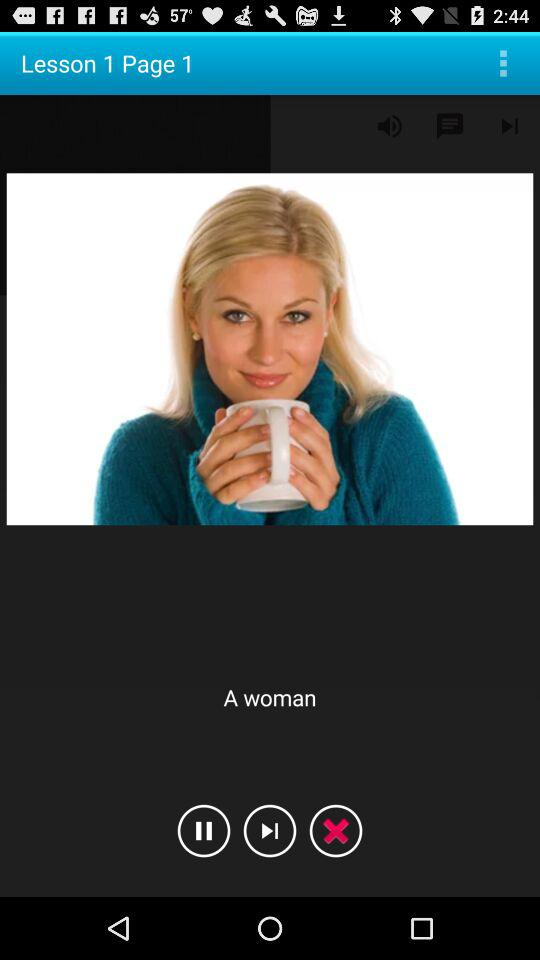Which lesson number is it? It is lesson 1. 